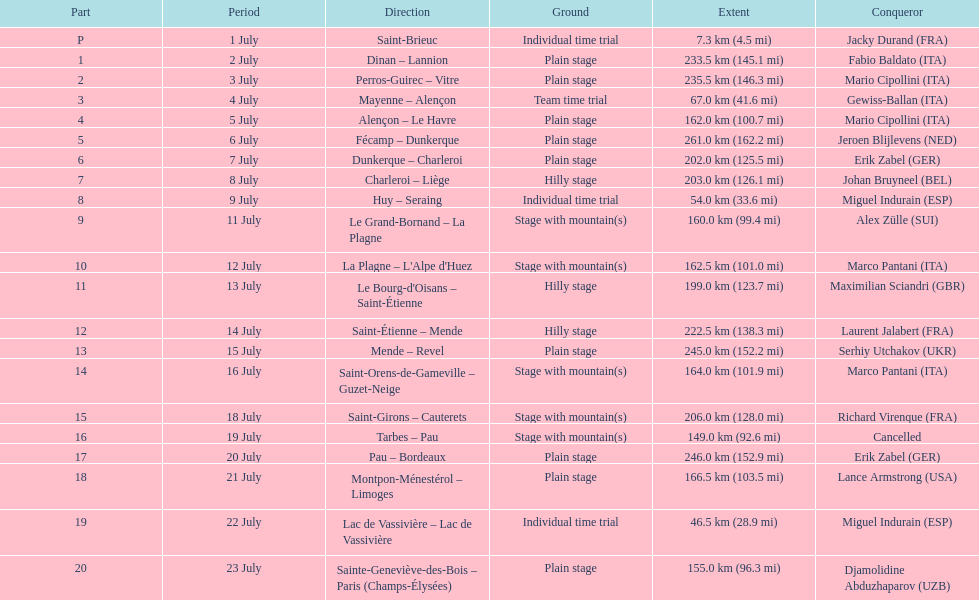How much longer is the 20th tour de france stage than the 19th? 108.5 km. 